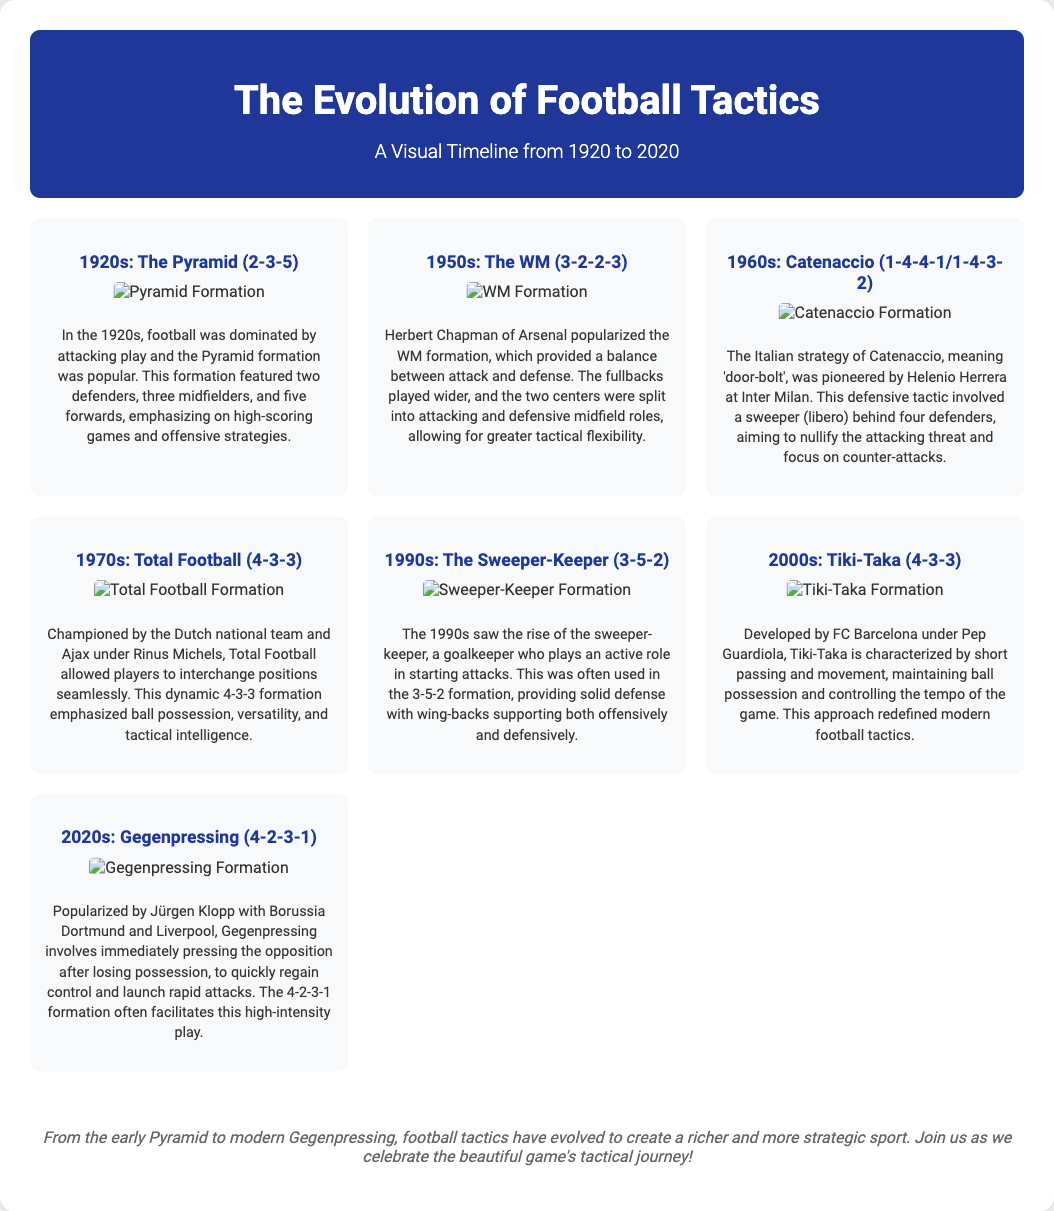What formation was popular in the 1920s? The 1920s section describes the Pyramid formation as the popular tactic during that time.
Answer: Pyramid (2-3-5) Who popularized the WM formation? The document states that Herbert Chapman of Arsenal was the one who popularized the WM formation.
Answer: Herbert Chapman What tactic is described as "door-bolt"? The term "Catenaccio" is explained in the 1960s section, meaning 'door-bolt' in Italian.
Answer: Catenaccio Which formation emphasizes ball possession and versatility? The section on Total Football in the 1970s highlights the focus on ball possession and player versatility.
Answer: 4-3-3 What is the main characteristic of Tiki-Taka? The 2000s section specifies that Tiki-Taka is characterized by short passing and movement.
Answer: Short passing and movement What was the primary role of the sweeper-keeper? The 1990s section explains that the sweeper-keeper plays an active role in starting attacks.
Answer: Starting attacks Which formation is associated with Gegenpressing? The 2020s section mentions that Gegenpressing often utilizes the 4-2-3-1 formation.
Answer: 4-2-3-1 What major change in tactics occurred from the 1950s to the 1970s? The comparison of tactics shows a shift from the WM formation to Total Football, emphasizing more dynamic play.
Answer: Shift to dynamic play What year range does the timeline cover? The title of the document indicates the time span from 1920 to 2020.
Answer: 1920 to 2020 